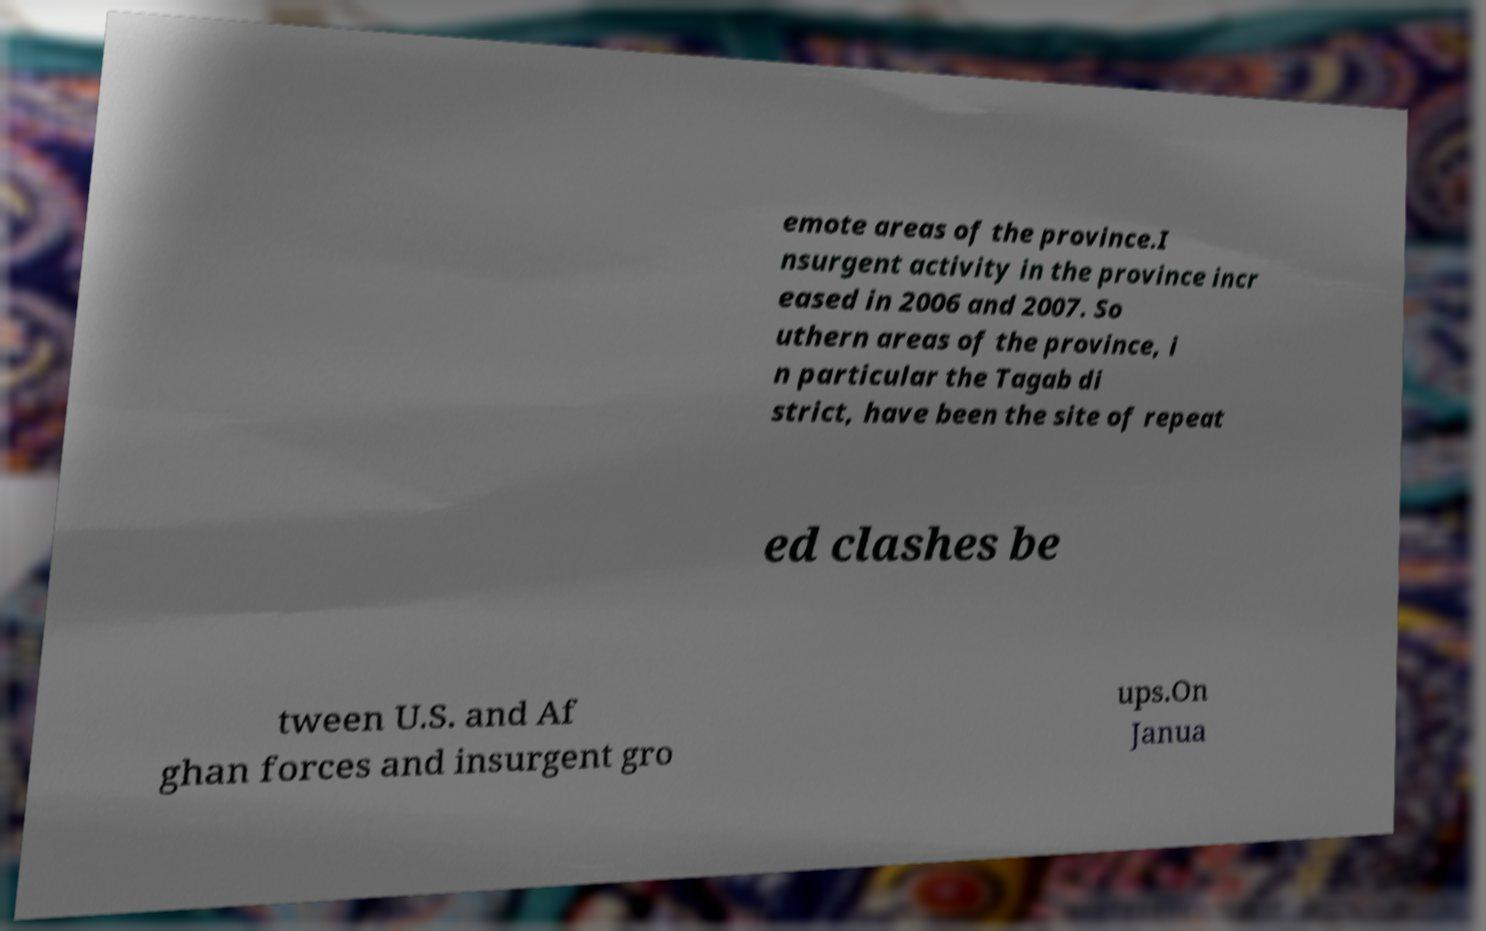There's text embedded in this image that I need extracted. Can you transcribe it verbatim? emote areas of the province.I nsurgent activity in the province incr eased in 2006 and 2007. So uthern areas of the province, i n particular the Tagab di strict, have been the site of repeat ed clashes be tween U.S. and Af ghan forces and insurgent gro ups.On Janua 